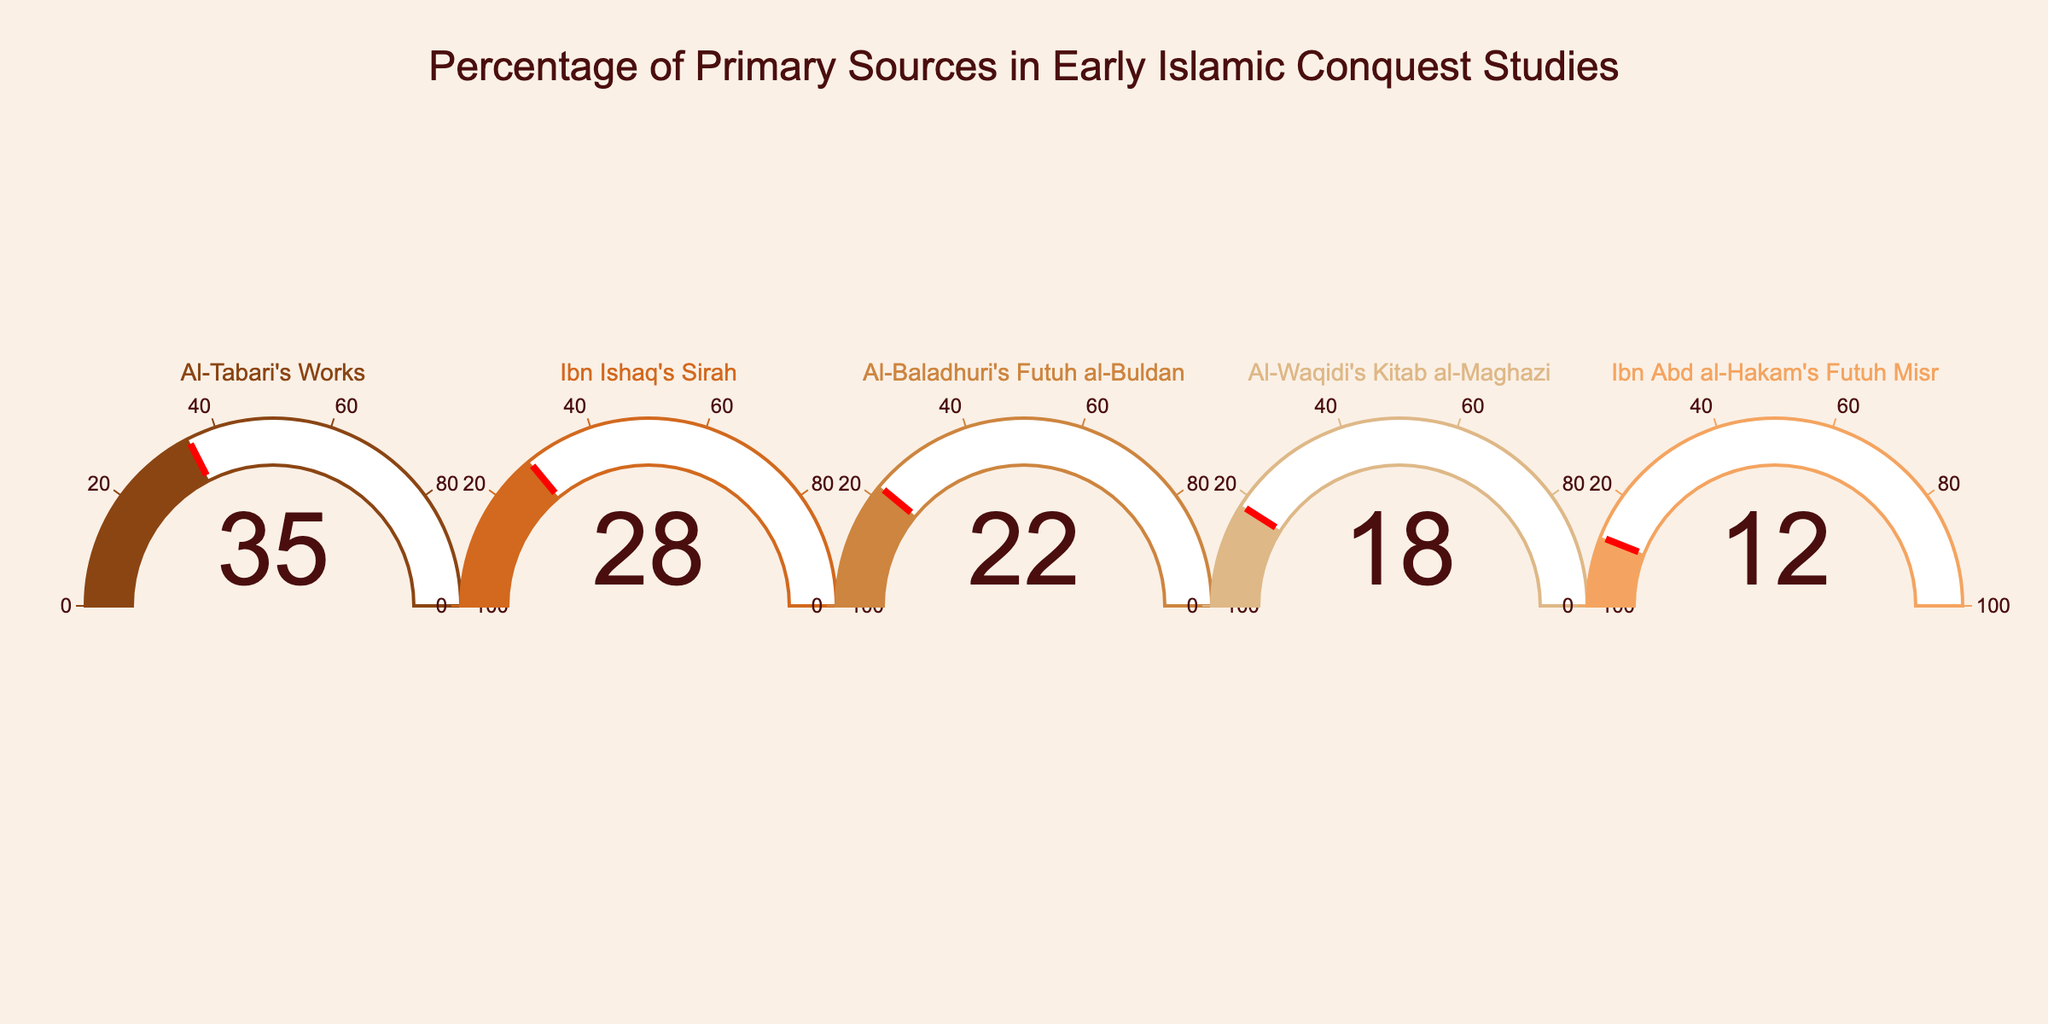What is the title of the figure? The title of the chart is displayed at the top and reads: "Percentage of Primary Sources in Early Islamic Conquest Studies"
Answer: Percentage of Primary Sources in Early Islamic Conquest Studies Which primary source has the highest percentage? Looking at the gauge charts, the primary source with the highest percentage is "Al-Tabari's Works" with 35%
Answer: Al-Tabari's Works What is the combined percentage of "Ibn Ishaq's Sirah" and "Al-Baladhuri's Futuh al-Buldan"? Summing the percentages from the two sources: "Ibn Ishaq's Sirah" is 28% and "Al-Baladhuri's Futuh al-Buldan" is 22%. Therefore, 28% + 22% = 50%
Answer: 50% Which source has a percentage closest to "Al-Waqidi's Kitab al-Maghazi"? "Al-Waqidi's Kitab al-Maghazi" is marked at 18%. The closest percentage to this is "Ibn Abd al-Hakam's Futuh Misr" with 12%
Answer: Ibn Abd al-Hakam's Futuh Misr Compare "Ibn Ishaq's Sirah" and "Ibn Abd al-Hakam's Futuh Misr". Which one has a higher percentage and by how much? "Ibn Ishaq's Sirah" has 28% and "Ibn Abd al-Hakam's Futuh Misr" has 12%. The difference is 28% - 12% = 16%
Answer: Ibn Ishaq's Sirah by 16% What range does the axis of the gauges indicate? Each gauge's axis runs from 0 to 100, as indicated by the tick marks on the gauges.
Answer: 0 to 100 What is the average percentage of all the primary sources listed? Summing all the percentages and dividing by the number of sources: (35 + 28 + 22 + 18 + 12) / 5 = 115 / 5 = 23%
Answer: 23% Which two sources together make up more than 50% of the primary sources? Adding the top two highest percentages, "Al-Tabari's Works" (35%) and "Ibn Ishaq's Sirah" (28%): 35% + 28% = 63%, which is more than 50%
Answer: Al-Tabari's Works and Ibn Ishaq's Sirah 